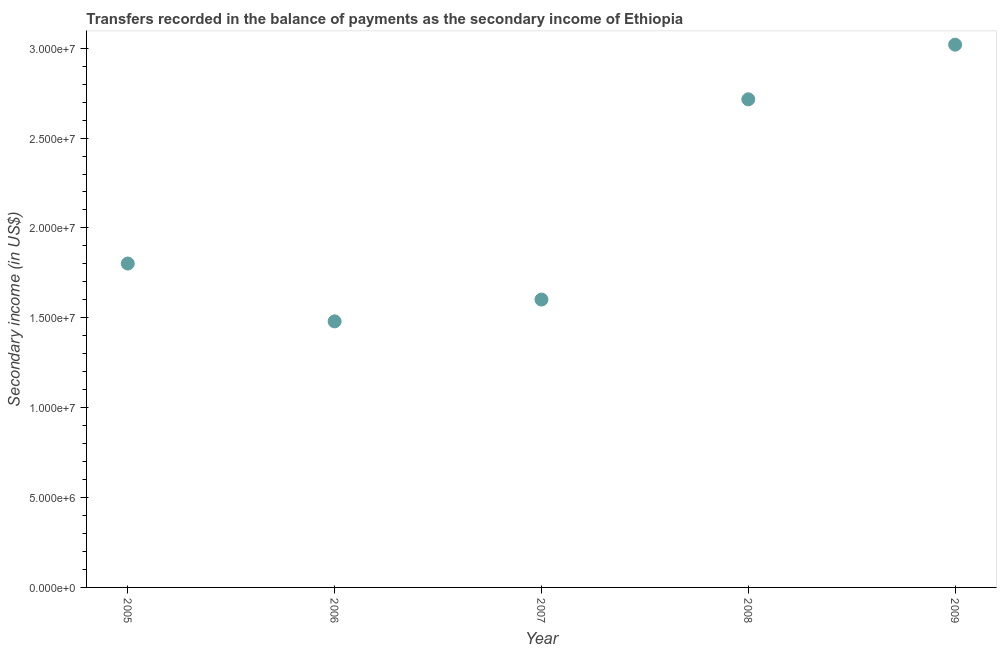What is the amount of secondary income in 2005?
Ensure brevity in your answer.  1.80e+07. Across all years, what is the maximum amount of secondary income?
Your answer should be compact. 3.02e+07. Across all years, what is the minimum amount of secondary income?
Keep it short and to the point. 1.48e+07. In which year was the amount of secondary income maximum?
Provide a succinct answer. 2009. What is the sum of the amount of secondary income?
Your response must be concise. 1.06e+08. What is the difference between the amount of secondary income in 2007 and 2008?
Provide a succinct answer. -1.11e+07. What is the average amount of secondary income per year?
Make the answer very short. 2.12e+07. What is the median amount of secondary income?
Your answer should be very brief. 1.80e+07. Do a majority of the years between 2009 and 2006 (inclusive) have amount of secondary income greater than 16000000 US$?
Your answer should be very brief. Yes. What is the ratio of the amount of secondary income in 2006 to that in 2008?
Ensure brevity in your answer.  0.55. What is the difference between the highest and the second highest amount of secondary income?
Offer a terse response. 3.04e+06. What is the difference between the highest and the lowest amount of secondary income?
Provide a short and direct response. 1.54e+07. Does the amount of secondary income monotonically increase over the years?
Provide a succinct answer. No. How many years are there in the graph?
Your answer should be compact. 5. Are the values on the major ticks of Y-axis written in scientific E-notation?
Ensure brevity in your answer.  Yes. Does the graph contain any zero values?
Ensure brevity in your answer.  No. Does the graph contain grids?
Keep it short and to the point. No. What is the title of the graph?
Make the answer very short. Transfers recorded in the balance of payments as the secondary income of Ethiopia. What is the label or title of the X-axis?
Your answer should be very brief. Year. What is the label or title of the Y-axis?
Ensure brevity in your answer.  Secondary income (in US$). What is the Secondary income (in US$) in 2005?
Provide a succinct answer. 1.80e+07. What is the Secondary income (in US$) in 2006?
Offer a terse response. 1.48e+07. What is the Secondary income (in US$) in 2007?
Keep it short and to the point. 1.60e+07. What is the Secondary income (in US$) in 2008?
Keep it short and to the point. 2.72e+07. What is the Secondary income (in US$) in 2009?
Your answer should be compact. 3.02e+07. What is the difference between the Secondary income (in US$) in 2005 and 2006?
Keep it short and to the point. 3.22e+06. What is the difference between the Secondary income (in US$) in 2005 and 2007?
Ensure brevity in your answer.  2.00e+06. What is the difference between the Secondary income (in US$) in 2005 and 2008?
Give a very brief answer. -9.14e+06. What is the difference between the Secondary income (in US$) in 2005 and 2009?
Your answer should be compact. -1.22e+07. What is the difference between the Secondary income (in US$) in 2006 and 2007?
Offer a terse response. -1.21e+06. What is the difference between the Secondary income (in US$) in 2006 and 2008?
Ensure brevity in your answer.  -1.24e+07. What is the difference between the Secondary income (in US$) in 2006 and 2009?
Make the answer very short. -1.54e+07. What is the difference between the Secondary income (in US$) in 2007 and 2008?
Your answer should be very brief. -1.11e+07. What is the difference between the Secondary income (in US$) in 2007 and 2009?
Ensure brevity in your answer.  -1.42e+07. What is the difference between the Secondary income (in US$) in 2008 and 2009?
Provide a short and direct response. -3.04e+06. What is the ratio of the Secondary income (in US$) in 2005 to that in 2006?
Offer a very short reply. 1.22. What is the ratio of the Secondary income (in US$) in 2005 to that in 2007?
Give a very brief answer. 1.12. What is the ratio of the Secondary income (in US$) in 2005 to that in 2008?
Offer a terse response. 0.66. What is the ratio of the Secondary income (in US$) in 2005 to that in 2009?
Provide a short and direct response. 0.6. What is the ratio of the Secondary income (in US$) in 2006 to that in 2007?
Make the answer very short. 0.92. What is the ratio of the Secondary income (in US$) in 2006 to that in 2008?
Keep it short and to the point. 0.55. What is the ratio of the Secondary income (in US$) in 2006 to that in 2009?
Your answer should be very brief. 0.49. What is the ratio of the Secondary income (in US$) in 2007 to that in 2008?
Provide a short and direct response. 0.59. What is the ratio of the Secondary income (in US$) in 2007 to that in 2009?
Ensure brevity in your answer.  0.53. What is the ratio of the Secondary income (in US$) in 2008 to that in 2009?
Offer a very short reply. 0.9. 